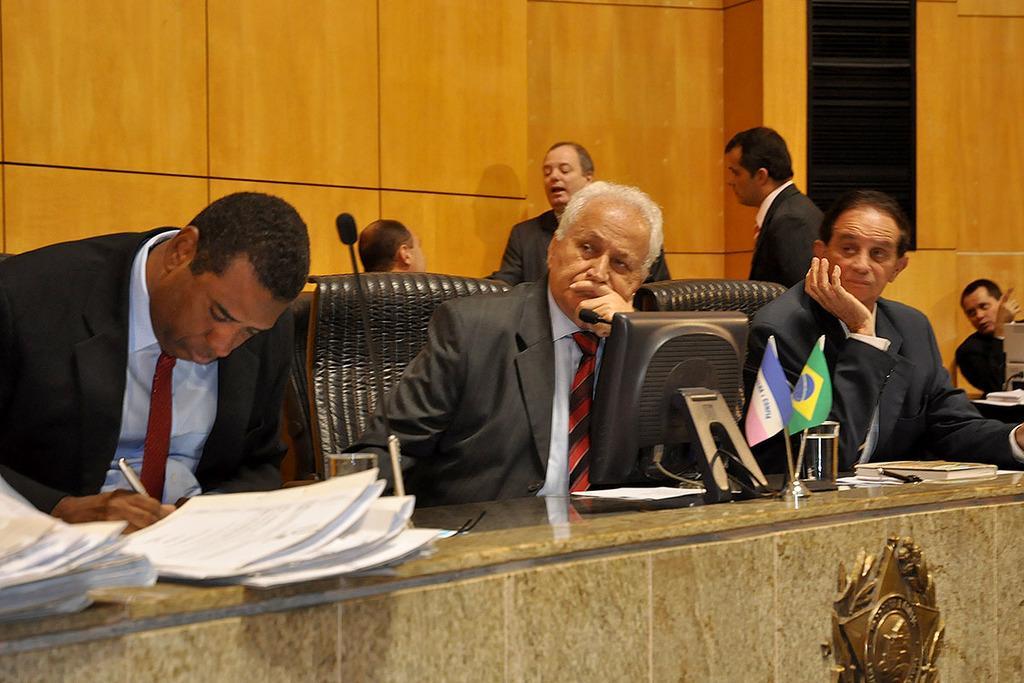Can you describe this image briefly? In this image there are people sitting on chairs, in front of them there is a table on that table there are papers computer, flags, glass, book, in the background there are two persons standing and there is a wooden wall. 